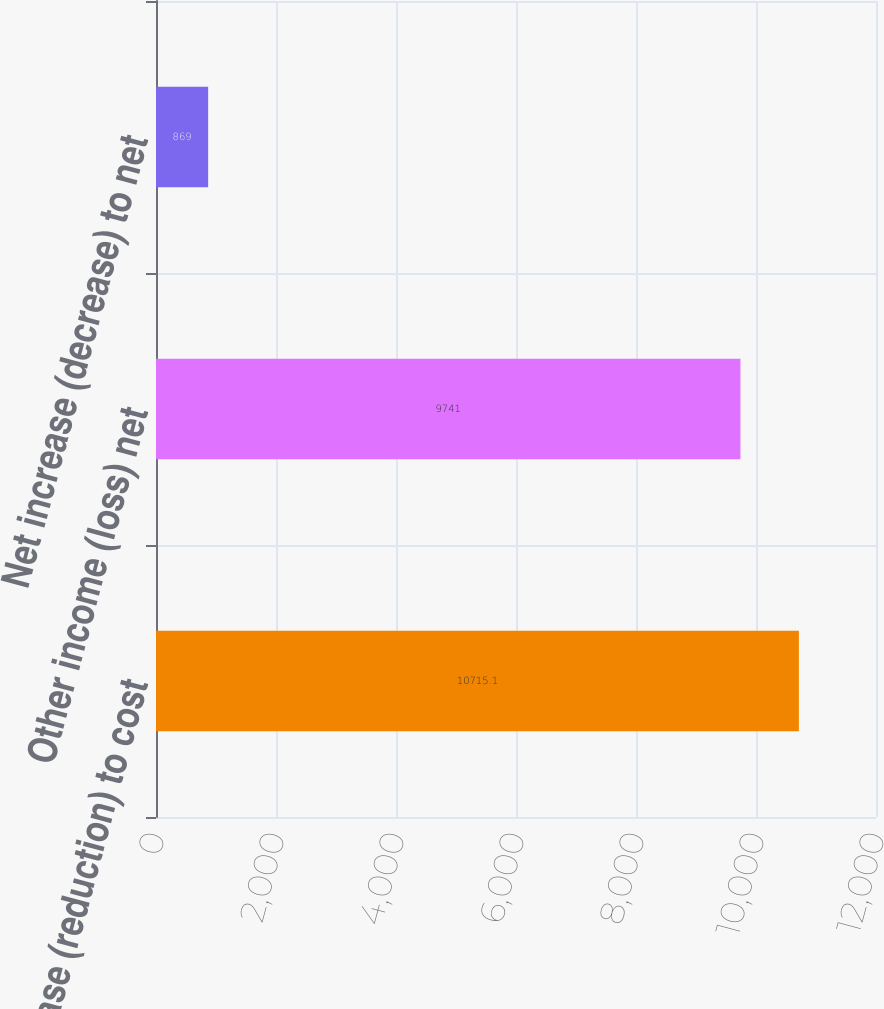<chart> <loc_0><loc_0><loc_500><loc_500><bar_chart><fcel>Increase (reduction) to cost<fcel>Other income (loss) net<fcel>Net increase (decrease) to net<nl><fcel>10715.1<fcel>9741<fcel>869<nl></chart> 